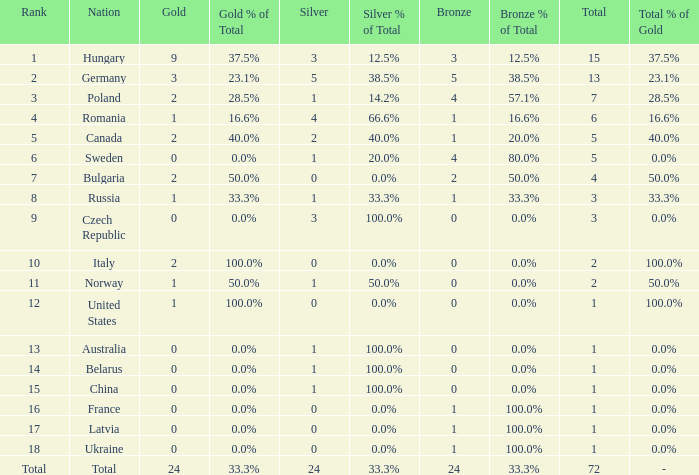What average total has 0 as the gold, with 6 as the rank? 5.0. 